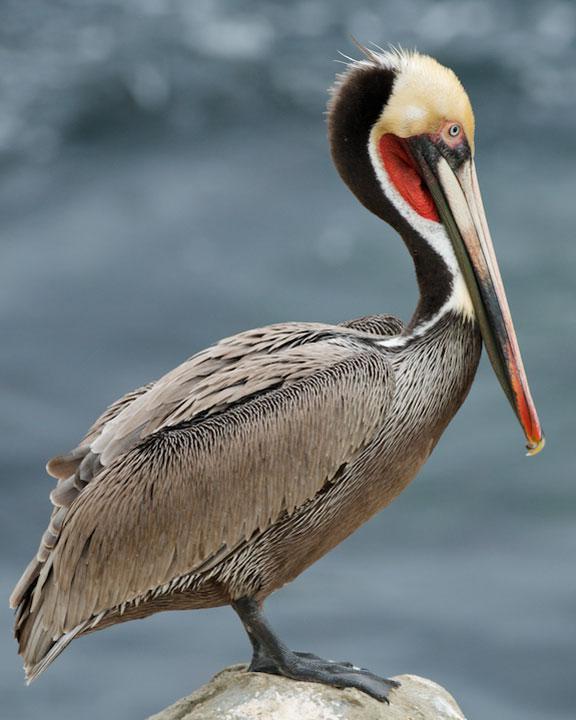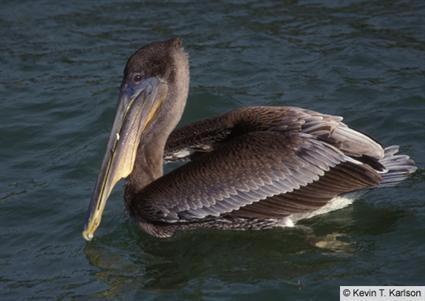The first image is the image on the left, the second image is the image on the right. Evaluate the accuracy of this statement regarding the images: "In both images a pelican's throat pouch is fully visible.". Is it true? Answer yes or no. No. The first image is the image on the left, the second image is the image on the right. Assess this claim about the two images: "The left image features one pelican standing on a smooth rock, and the right image features one pelican swimming on water.". Correct or not? Answer yes or no. Yes. 